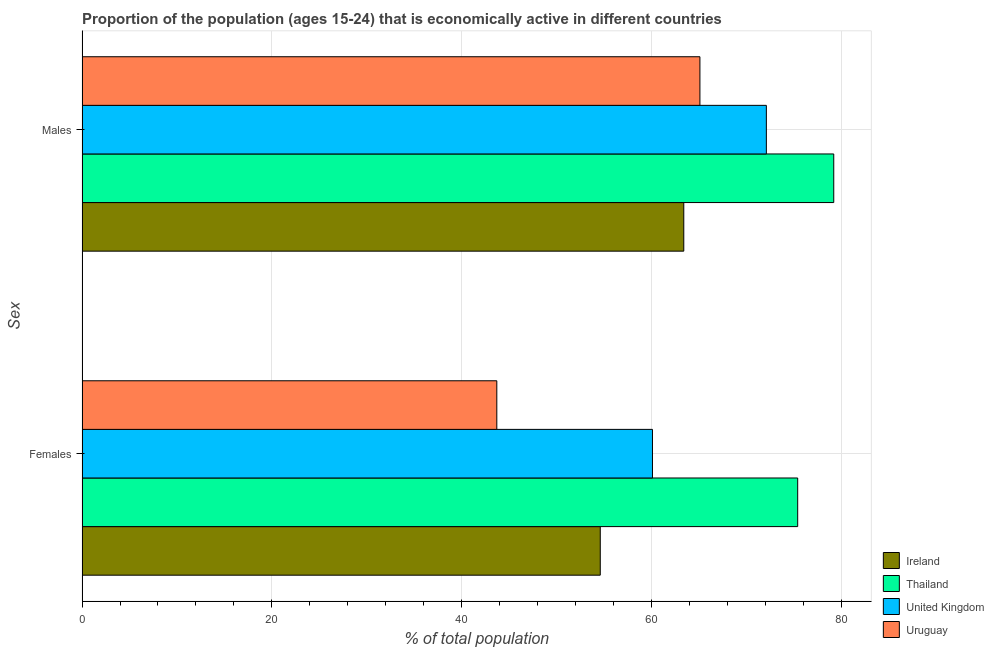How many groups of bars are there?
Your answer should be very brief. 2. Are the number of bars per tick equal to the number of legend labels?
Keep it short and to the point. Yes. How many bars are there on the 1st tick from the bottom?
Your answer should be very brief. 4. What is the label of the 2nd group of bars from the top?
Give a very brief answer. Females. What is the percentage of economically active female population in Thailand?
Provide a short and direct response. 75.4. Across all countries, what is the maximum percentage of economically active female population?
Your response must be concise. 75.4. Across all countries, what is the minimum percentage of economically active male population?
Offer a very short reply. 63.4. In which country was the percentage of economically active male population maximum?
Make the answer very short. Thailand. In which country was the percentage of economically active female population minimum?
Your response must be concise. Uruguay. What is the total percentage of economically active female population in the graph?
Offer a very short reply. 233.8. What is the difference between the percentage of economically active male population in Uruguay and that in Thailand?
Keep it short and to the point. -14.1. What is the difference between the percentage of economically active female population in Uruguay and the percentage of economically active male population in Thailand?
Your answer should be compact. -35.5. What is the average percentage of economically active male population per country?
Provide a short and direct response. 69.95. What is the difference between the percentage of economically active male population and percentage of economically active female population in Uruguay?
Give a very brief answer. 21.4. What is the ratio of the percentage of economically active male population in United Kingdom to that in Ireland?
Offer a very short reply. 1.14. Is the percentage of economically active female population in Thailand less than that in Ireland?
Ensure brevity in your answer.  No. What does the 1st bar from the top in Females represents?
Provide a short and direct response. Uruguay. What does the 4th bar from the bottom in Females represents?
Offer a very short reply. Uruguay. How many bars are there?
Your answer should be compact. 8. Are all the bars in the graph horizontal?
Provide a short and direct response. Yes. Are the values on the major ticks of X-axis written in scientific E-notation?
Your response must be concise. No. Does the graph contain any zero values?
Offer a terse response. No. Does the graph contain grids?
Give a very brief answer. Yes. Where does the legend appear in the graph?
Ensure brevity in your answer.  Bottom right. How many legend labels are there?
Your response must be concise. 4. What is the title of the graph?
Your answer should be very brief. Proportion of the population (ages 15-24) that is economically active in different countries. What is the label or title of the X-axis?
Your answer should be very brief. % of total population. What is the label or title of the Y-axis?
Provide a succinct answer. Sex. What is the % of total population in Ireland in Females?
Provide a succinct answer. 54.6. What is the % of total population in Thailand in Females?
Your answer should be very brief. 75.4. What is the % of total population of United Kingdom in Females?
Offer a very short reply. 60.1. What is the % of total population of Uruguay in Females?
Give a very brief answer. 43.7. What is the % of total population of Ireland in Males?
Your response must be concise. 63.4. What is the % of total population of Thailand in Males?
Make the answer very short. 79.2. What is the % of total population of United Kingdom in Males?
Ensure brevity in your answer.  72.1. What is the % of total population of Uruguay in Males?
Your answer should be compact. 65.1. Across all Sex, what is the maximum % of total population of Ireland?
Your answer should be very brief. 63.4. Across all Sex, what is the maximum % of total population in Thailand?
Give a very brief answer. 79.2. Across all Sex, what is the maximum % of total population in United Kingdom?
Your answer should be very brief. 72.1. Across all Sex, what is the maximum % of total population of Uruguay?
Ensure brevity in your answer.  65.1. Across all Sex, what is the minimum % of total population in Ireland?
Give a very brief answer. 54.6. Across all Sex, what is the minimum % of total population in Thailand?
Ensure brevity in your answer.  75.4. Across all Sex, what is the minimum % of total population of United Kingdom?
Give a very brief answer. 60.1. Across all Sex, what is the minimum % of total population in Uruguay?
Provide a succinct answer. 43.7. What is the total % of total population of Ireland in the graph?
Offer a terse response. 118. What is the total % of total population in Thailand in the graph?
Your response must be concise. 154.6. What is the total % of total population in United Kingdom in the graph?
Give a very brief answer. 132.2. What is the total % of total population in Uruguay in the graph?
Your answer should be compact. 108.8. What is the difference between the % of total population in Ireland in Females and that in Males?
Make the answer very short. -8.8. What is the difference between the % of total population of Thailand in Females and that in Males?
Offer a very short reply. -3.8. What is the difference between the % of total population of Uruguay in Females and that in Males?
Offer a terse response. -21.4. What is the difference between the % of total population of Ireland in Females and the % of total population of Thailand in Males?
Ensure brevity in your answer.  -24.6. What is the difference between the % of total population in Ireland in Females and the % of total population in United Kingdom in Males?
Offer a very short reply. -17.5. What is the difference between the % of total population in Ireland in Females and the % of total population in Uruguay in Males?
Provide a succinct answer. -10.5. What is the difference between the % of total population of Thailand in Females and the % of total population of Uruguay in Males?
Your answer should be compact. 10.3. What is the average % of total population of Ireland per Sex?
Provide a short and direct response. 59. What is the average % of total population of Thailand per Sex?
Ensure brevity in your answer.  77.3. What is the average % of total population in United Kingdom per Sex?
Your answer should be very brief. 66.1. What is the average % of total population in Uruguay per Sex?
Ensure brevity in your answer.  54.4. What is the difference between the % of total population in Ireland and % of total population in Thailand in Females?
Make the answer very short. -20.8. What is the difference between the % of total population of Thailand and % of total population of United Kingdom in Females?
Your answer should be compact. 15.3. What is the difference between the % of total population in Thailand and % of total population in Uruguay in Females?
Provide a succinct answer. 31.7. What is the difference between the % of total population in Ireland and % of total population in Thailand in Males?
Offer a terse response. -15.8. What is the difference between the % of total population of Ireland and % of total population of United Kingdom in Males?
Make the answer very short. -8.7. What is the difference between the % of total population in Ireland and % of total population in Uruguay in Males?
Give a very brief answer. -1.7. What is the difference between the % of total population in Thailand and % of total population in United Kingdom in Males?
Give a very brief answer. 7.1. What is the ratio of the % of total population of Ireland in Females to that in Males?
Offer a terse response. 0.86. What is the ratio of the % of total population in Thailand in Females to that in Males?
Provide a short and direct response. 0.95. What is the ratio of the % of total population in United Kingdom in Females to that in Males?
Provide a short and direct response. 0.83. What is the ratio of the % of total population of Uruguay in Females to that in Males?
Your answer should be compact. 0.67. What is the difference between the highest and the second highest % of total population in Ireland?
Your answer should be very brief. 8.8. What is the difference between the highest and the second highest % of total population in United Kingdom?
Offer a very short reply. 12. What is the difference between the highest and the second highest % of total population in Uruguay?
Keep it short and to the point. 21.4. What is the difference between the highest and the lowest % of total population in Uruguay?
Make the answer very short. 21.4. 